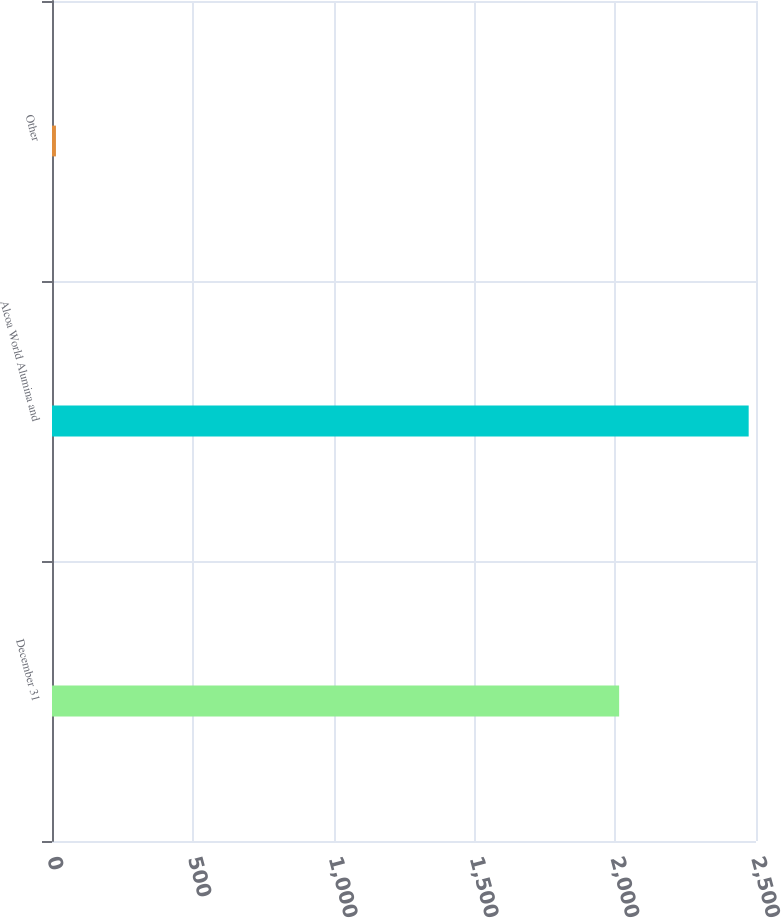Convert chart to OTSL. <chart><loc_0><loc_0><loc_500><loc_500><bar_chart><fcel>December 31<fcel>Alcoa World Alumina and<fcel>Other<nl><fcel>2014<fcel>2474<fcel>14<nl></chart> 